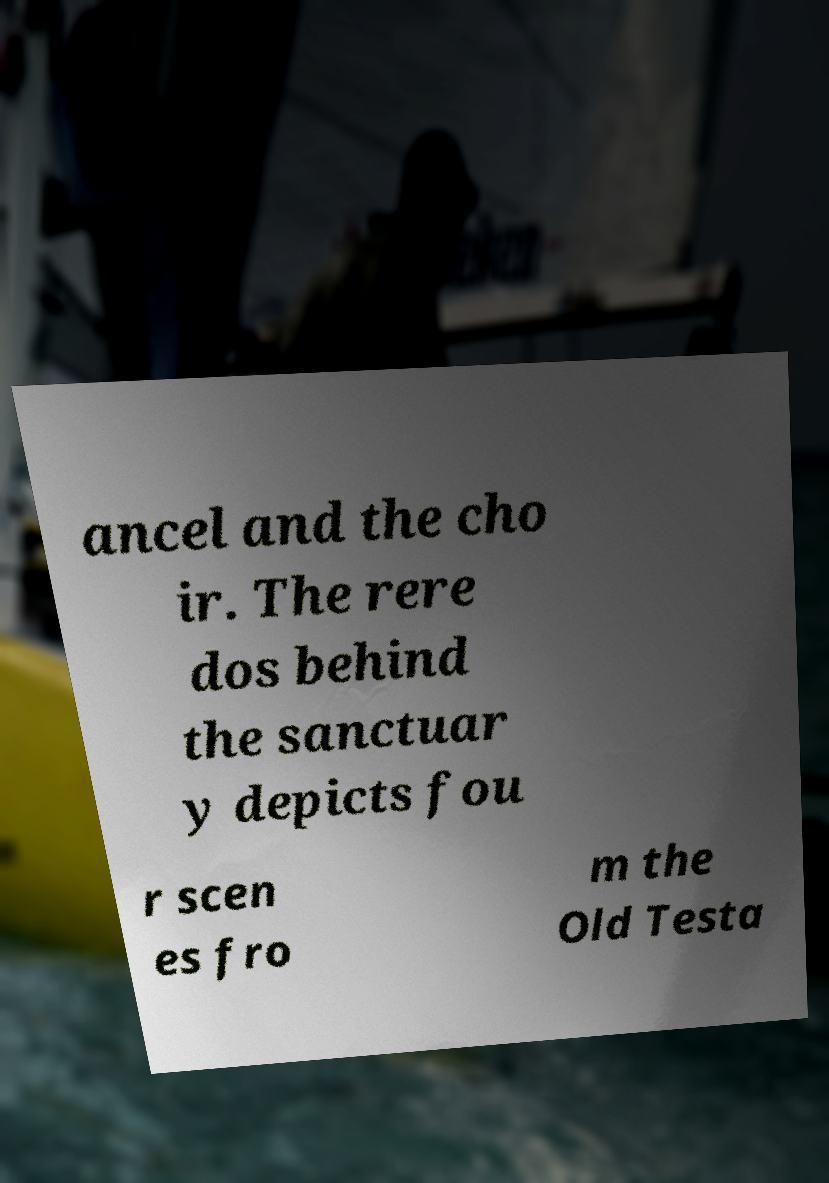There's text embedded in this image that I need extracted. Can you transcribe it verbatim? ancel and the cho ir. The rere dos behind the sanctuar y depicts fou r scen es fro m the Old Testa 